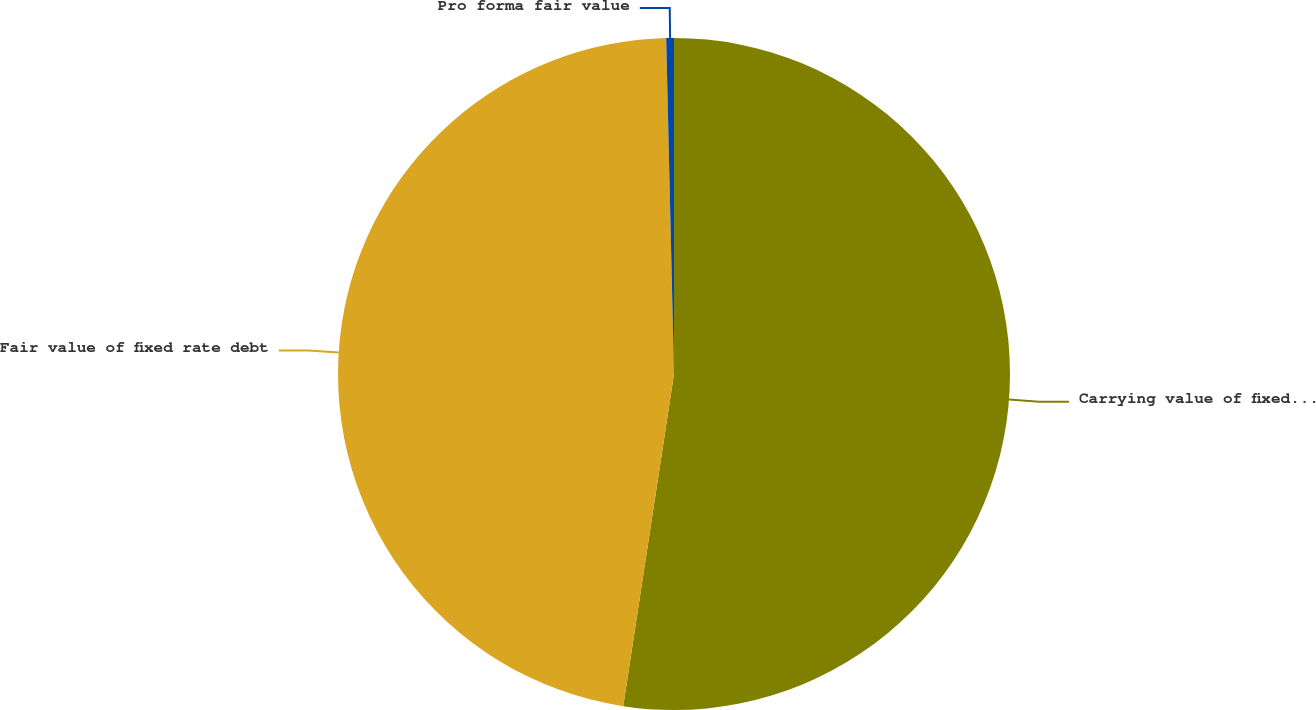Convert chart to OTSL. <chart><loc_0><loc_0><loc_500><loc_500><pie_chart><fcel>Carrying value of fixed rate<fcel>Fair value of fixed rate debt<fcel>Pro forma fair value<nl><fcel>52.42%<fcel>47.22%<fcel>0.37%<nl></chart> 